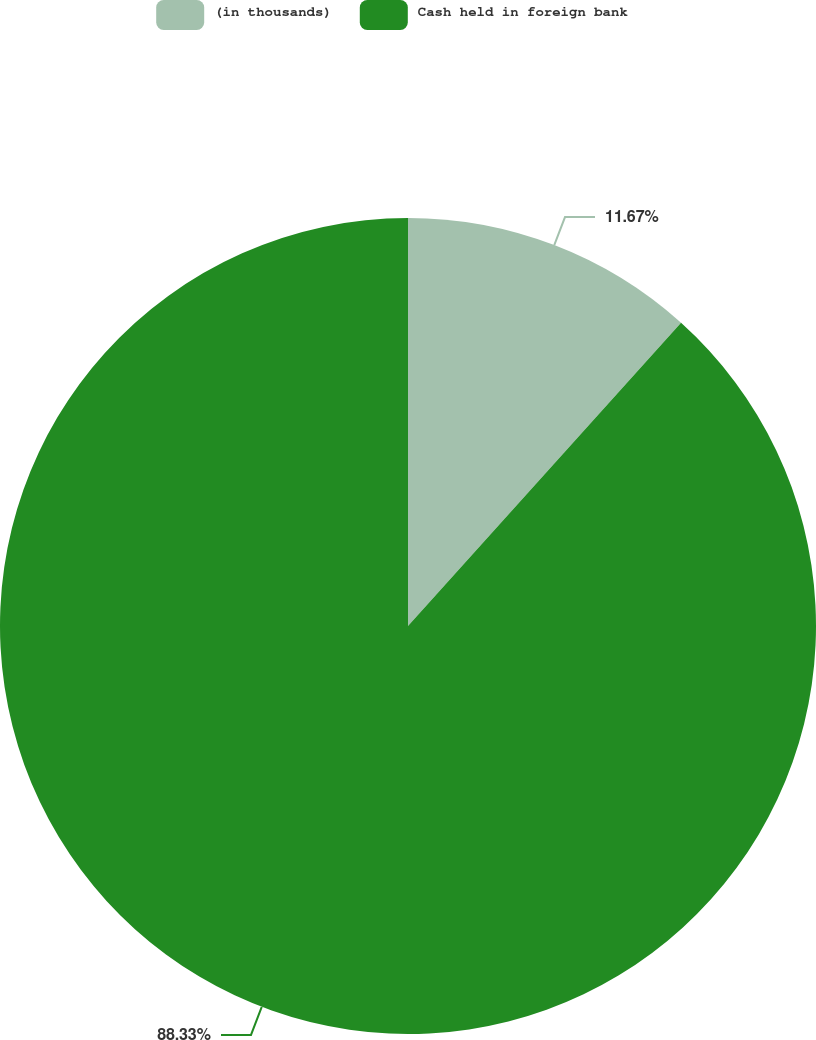Convert chart to OTSL. <chart><loc_0><loc_0><loc_500><loc_500><pie_chart><fcel>(in thousands)<fcel>Cash held in foreign bank<nl><fcel>11.67%<fcel>88.33%<nl></chart> 